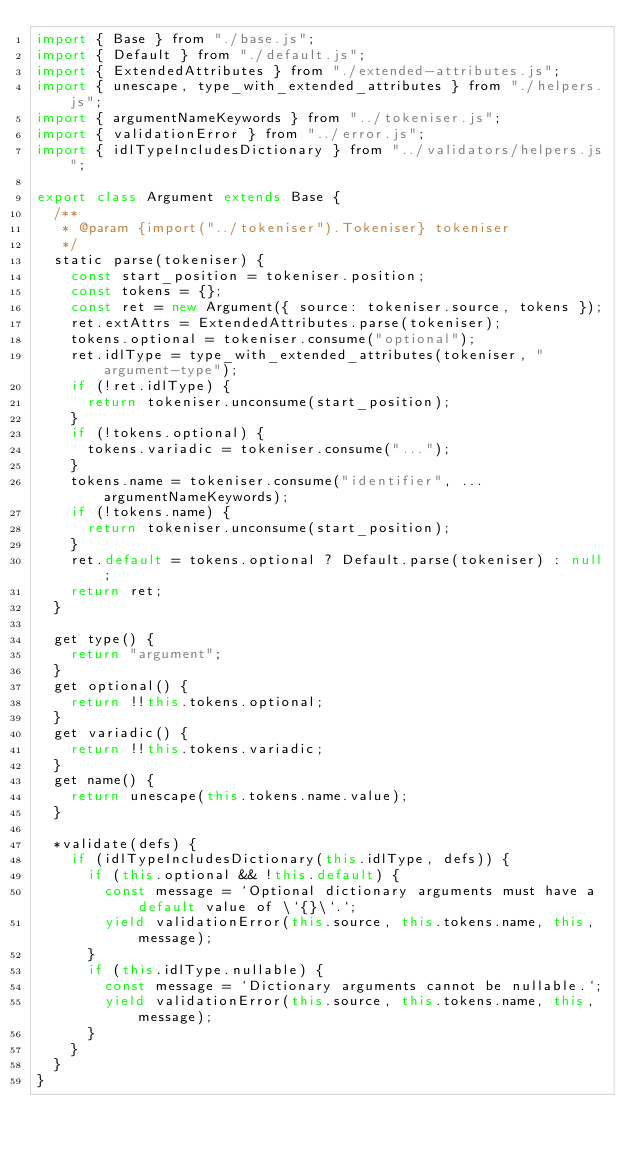Convert code to text. <code><loc_0><loc_0><loc_500><loc_500><_JavaScript_>import { Base } from "./base.js";
import { Default } from "./default.js";
import { ExtendedAttributes } from "./extended-attributes.js";
import { unescape, type_with_extended_attributes } from "./helpers.js";
import { argumentNameKeywords } from "../tokeniser.js";
import { validationError } from "../error.js";
import { idlTypeIncludesDictionary } from "../validators/helpers.js";

export class Argument extends Base {
  /**
   * @param {import("../tokeniser").Tokeniser} tokeniser
   */
  static parse(tokeniser) {
    const start_position = tokeniser.position;
    const tokens = {};
    const ret = new Argument({ source: tokeniser.source, tokens });
    ret.extAttrs = ExtendedAttributes.parse(tokeniser);
    tokens.optional = tokeniser.consume("optional");
    ret.idlType = type_with_extended_attributes(tokeniser, "argument-type");
    if (!ret.idlType) {
      return tokeniser.unconsume(start_position);
    }
    if (!tokens.optional) {
      tokens.variadic = tokeniser.consume("...");
    }
    tokens.name = tokeniser.consume("identifier", ...argumentNameKeywords);
    if (!tokens.name) {
      return tokeniser.unconsume(start_position);
    }
    ret.default = tokens.optional ? Default.parse(tokeniser) : null;
    return ret;
  }

  get type() {
    return "argument";
  }
  get optional() {
    return !!this.tokens.optional;
  }
  get variadic() {
    return !!this.tokens.variadic;
  }
  get name() {
    return unescape(this.tokens.name.value);
  }

  *validate(defs) {
    if (idlTypeIncludesDictionary(this.idlType, defs)) {
      if (this.optional && !this.default) {
        const message = `Optional dictionary arguments must have a default value of \`{}\`.`;
        yield validationError(this.source, this.tokens.name, this, message);
      }
      if (this.idlType.nullable) {
        const message = `Dictionary arguments cannot be nullable.`;
        yield validationError(this.source, this.tokens.name, this, message);
      }
    }
  }
}
</code> 